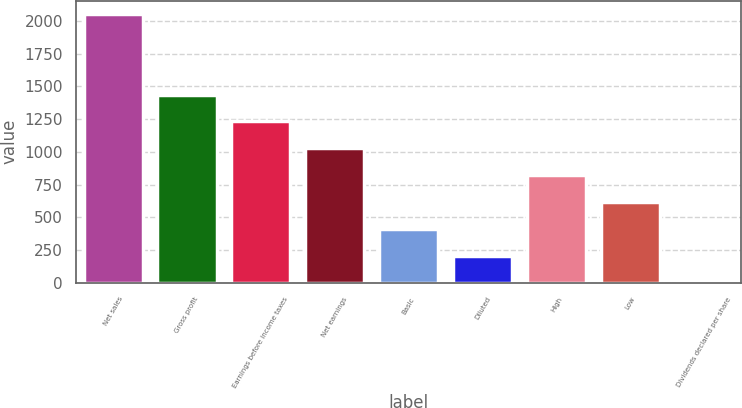Convert chart to OTSL. <chart><loc_0><loc_0><loc_500><loc_500><bar_chart><fcel>Net sales<fcel>Gross profit<fcel>Earnings before income taxes<fcel>Net earnings<fcel>Basic<fcel>Diluted<fcel>High<fcel>Low<fcel>Dividends declared per share<nl><fcel>2052<fcel>1436.47<fcel>1231.29<fcel>1026.11<fcel>410.57<fcel>205.39<fcel>820.93<fcel>615.75<fcel>0.21<nl></chart> 